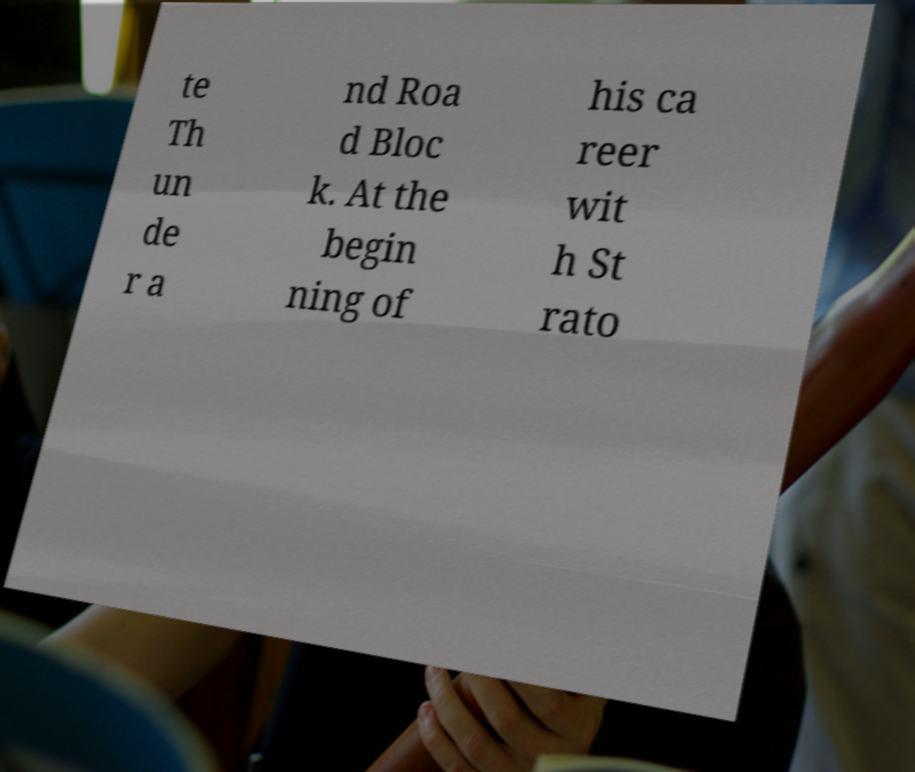I need the written content from this picture converted into text. Can you do that? te Th un de r a nd Roa d Bloc k. At the begin ning of his ca reer wit h St rato 